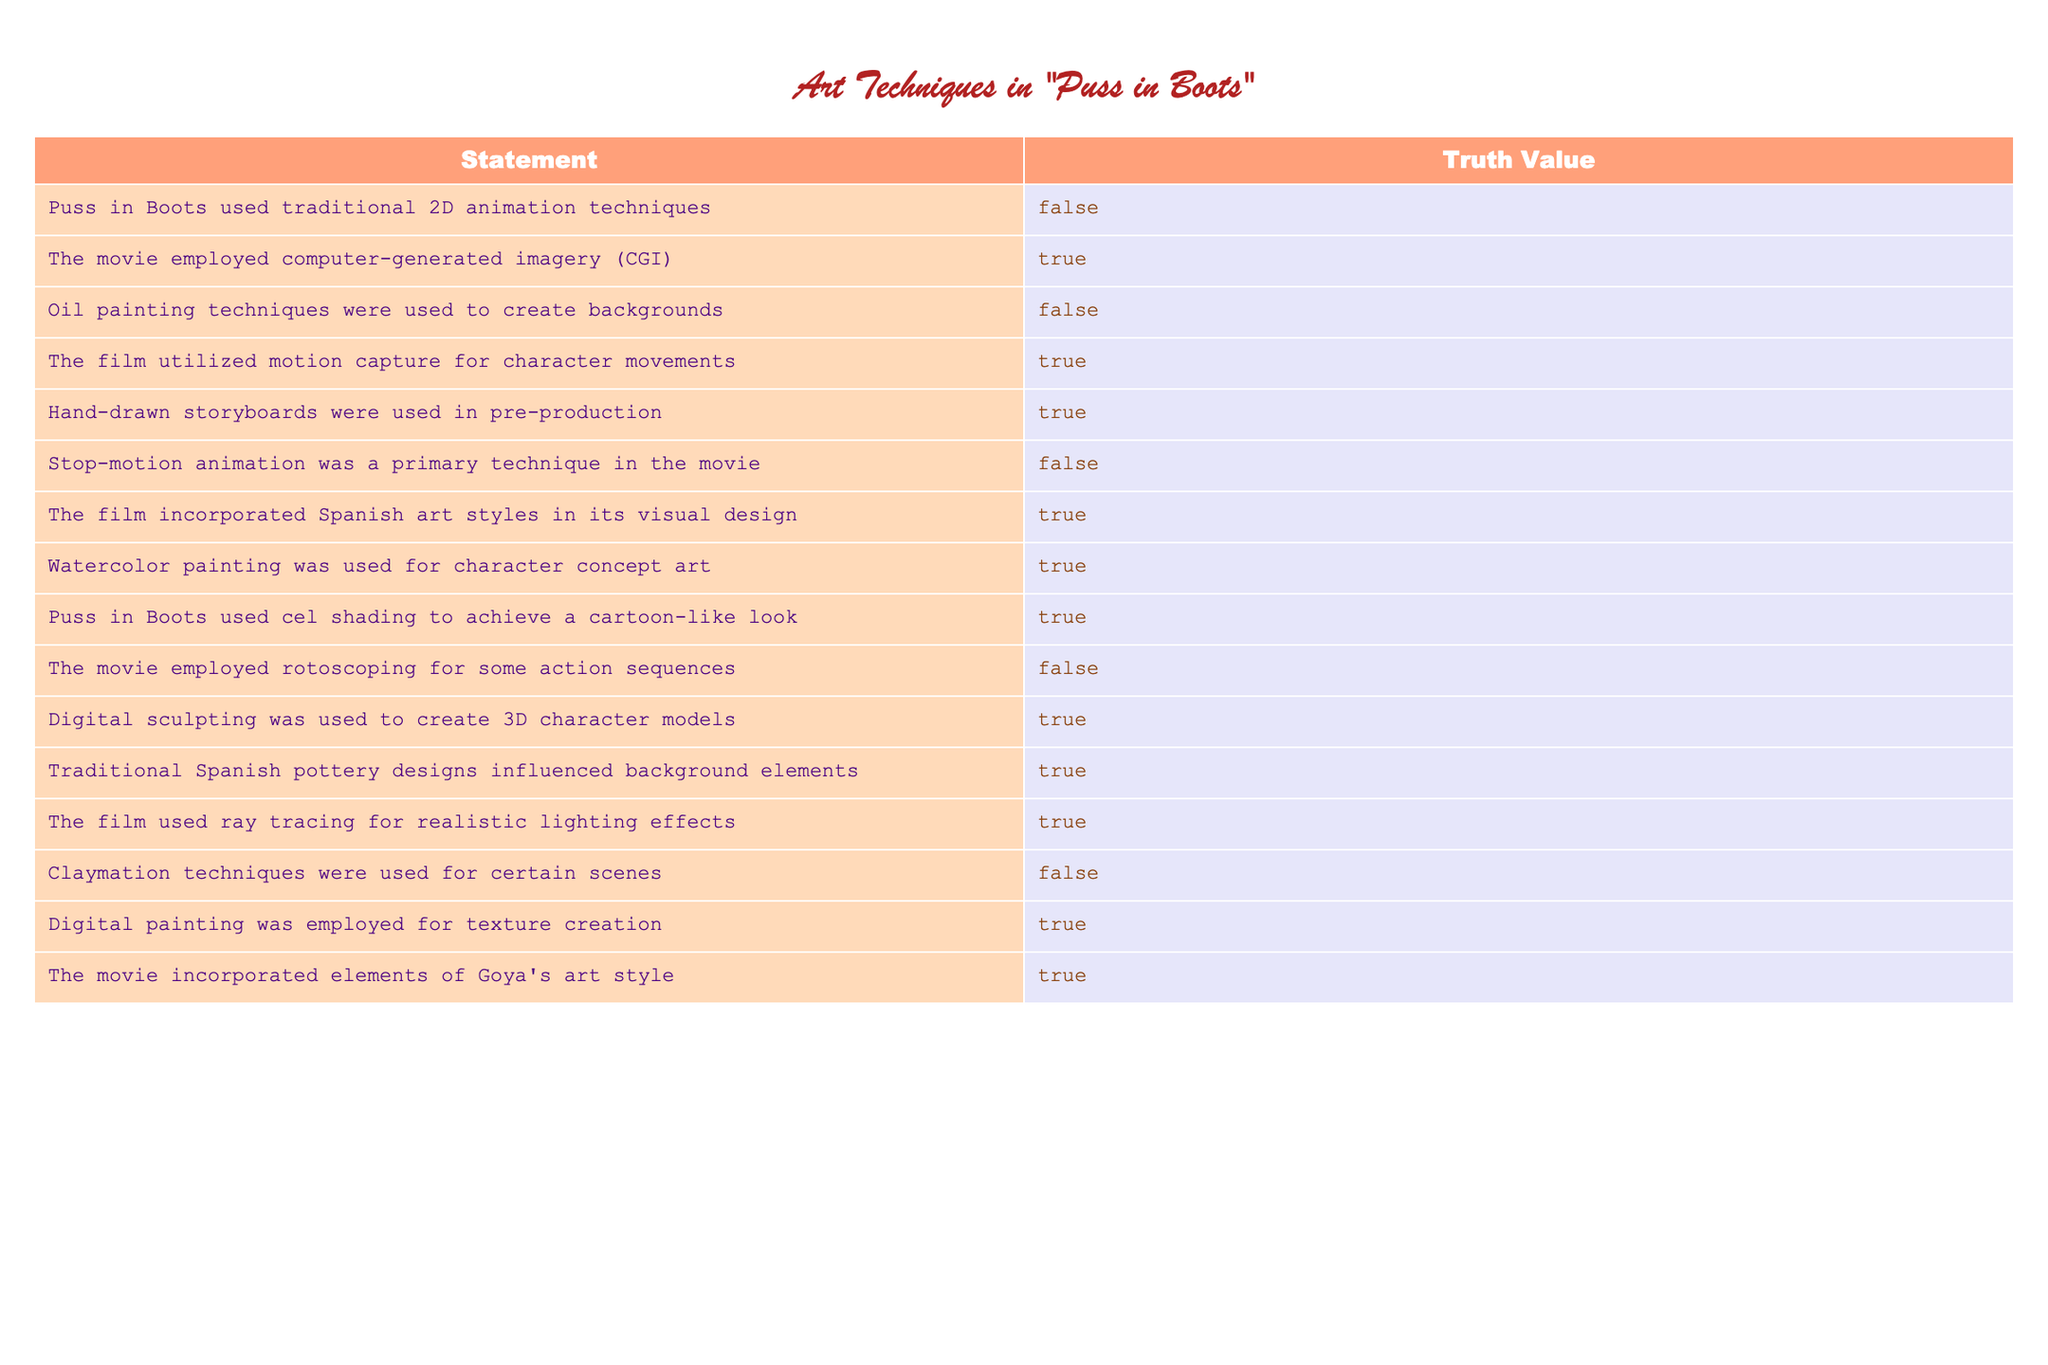What animation technique was primarily used in "Puss in Boots"? The statement indicates that traditional 2D animation techniques were used, but the truth value in the table shows this is FALSE. Therefore, another technique must have been employed instead.
Answer: Not traditional 2D animation Was CGI utilized in the movie? According to the table, the statement about employing computer-generated imagery states TRUE. Thus, CGI was indeed used in "Puss in Boots."
Answer: Yes How many techniques involving traditional art forms were used? The table lists several statements; we focus on any truth values marked TRUE for traditional art forms. Those include Spanish art styles, oil painting techniques, and traditional pottery designs. "Puss in Boots" incorporated 4 techniques total.
Answer: 4 Did the film use any watercolor painting techniques? The table confirms that watercolor painting was utilized for character concept art, marking this statement as TRUE. Thus, the answer is that watercolor techniques were indeed used.
Answer: Yes What percentage of the techniques listed were not used in "Puss in Boots"? Counting the FALSE values, we have 5 out of 15 total statements. To find the percentage: (5/15) * 100 = 33.33%. Therefore, 33.33% of techniques mentioned were not used.
Answer: 33.33% Were hand-drawn storyboards employed during pre-production? The table indicates that hand-drawn storyboards were used, marked as TRUE. Thus, this technique was indeed part of the movie's pre-production process.
Answer: Yes How many techniques employed digital art methods? Looking at the data, the techniques using digital methods list as TRUE are digital sculpting, digital painting, and CGI. This gives us a total of 4 techniques using digital arts.
Answer: 4 Did "Puss in Boots" make use of motion capture? The statement that the film utilized motion capture for character movements is marked TRUE in the table. Therefore, motion capture was a technique used in the film.
Answer: Yes How many visual art techniques mentioned in the table involve realism in their style? The truth values indicate ray tracing for realistic lighting effects and CGI as techniques revealing realistic appearance. Thus, there are 2 techniques related to realism noted in the table.
Answer: 2 